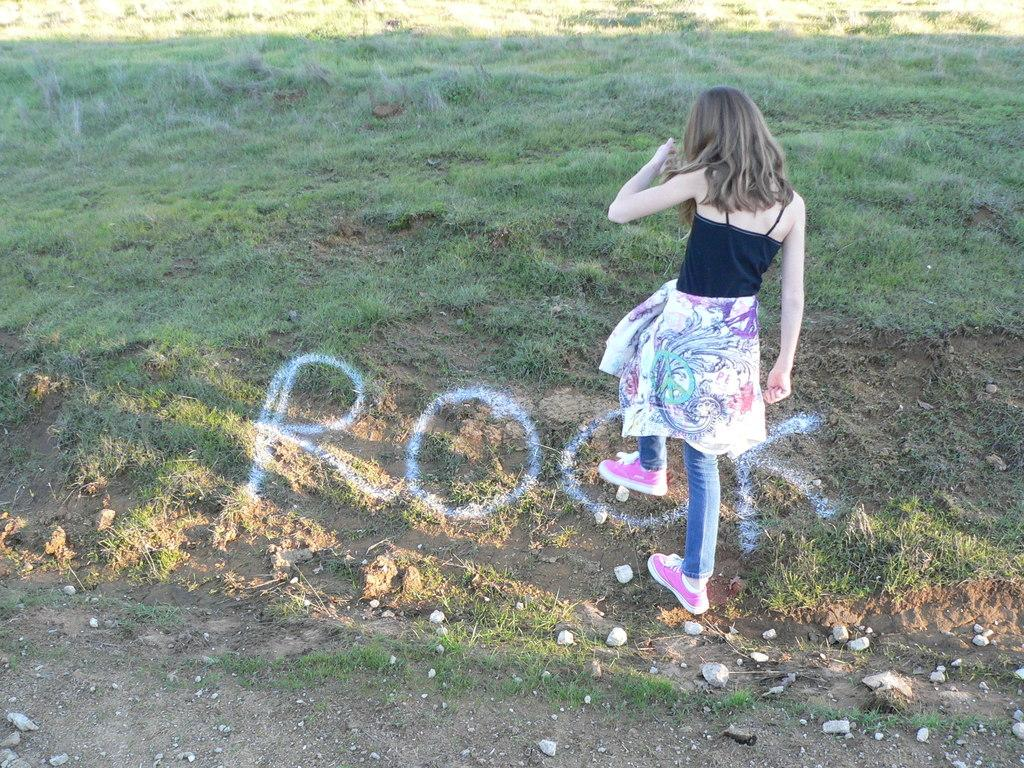Who is the main subject in the foreground of the image? There is a girl in the foreground of the image. What color are the shoes the girl is wearing? The girl is wearing pink shoes. What type of pants is the girl wearing? The girl is wearing blue jeans. What can be seen at the bottom of the image? There is some text at the bottom of the image. What type of natural environment is visible in the background of the image? There is grass visible in the background of the image. What type of cork can be seen in the image? There is no cork present in the image. Is the girl preparing a stew in the image? There is no indication of food preparation or a stew in the image. 